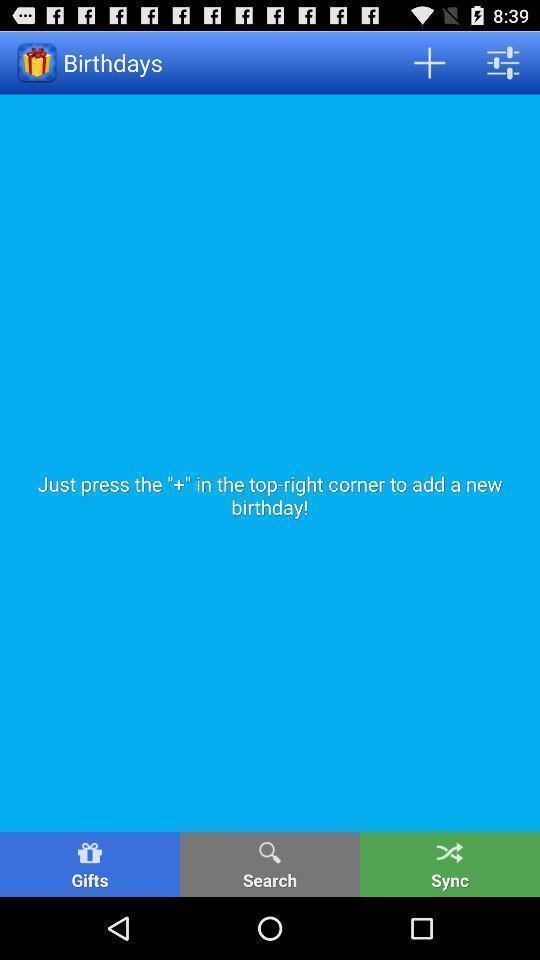Summarize the information in this screenshot. Page displaying to add reminders for application with other options. 